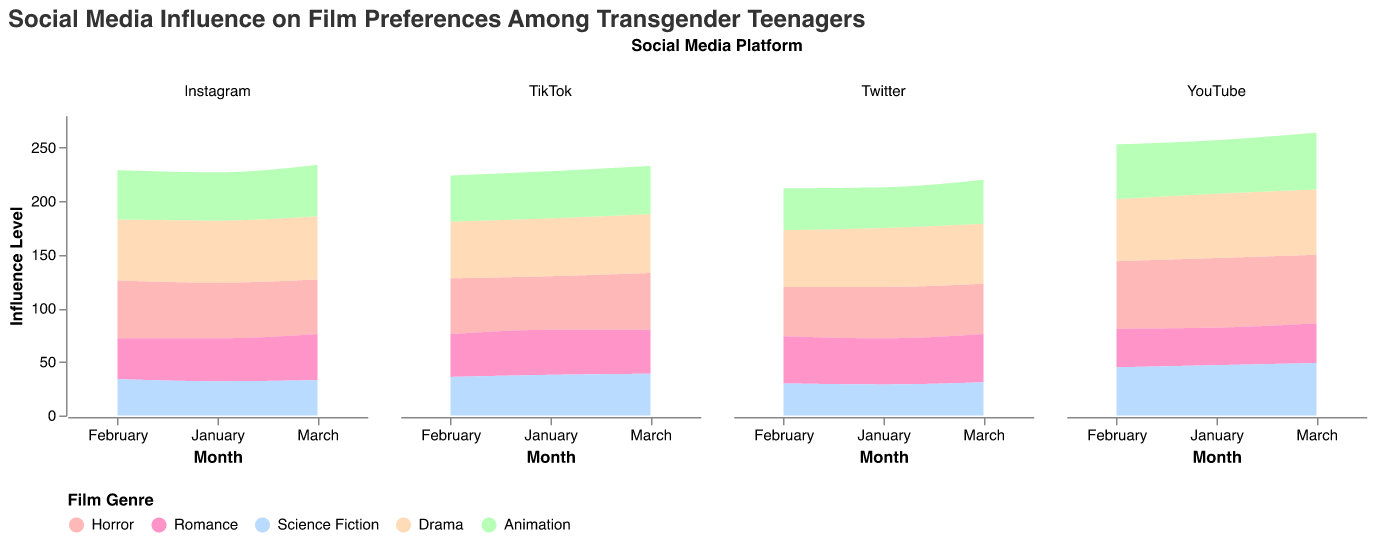What is the title of the figure? The title is displayed at the top of the chart and it briefly explains the content of the figure.
Answer: Social Media Influence on Film Preferences Among Transgender Teenagers Which month has the highest influence level for Horror films on YouTube? For YouTube, look at the area chart for the Horror genre across all months. Identify the month with the highest peak.
Answer: January What genre has the lowest influence level on Twitter in February? Refer to the Twitter subplot and look at the February data. Compare the influence levels of all genres.
Answer: Science Fiction Which platform shows the highest increase in influence level for Drama from January to March? Compare the Drama trends on each platform from January to March. The highest increase is identified by the steepest upward slope.
Answer: YouTube What is the average influence level for Romance on Instagram across the three months? Add up the Romance influence levels on Instagram for January (40), February (38), and March (43), then divide by 3.
Answer: 40.33 Between TikTok and Instagram, which platform has a higher total influence level for Science Fiction in March? Compare the sum of the influence levels for Science Fiction in March for TikTok (39) and Instagram (33).
Answer: TikTok How does the influence level for Animation on Twitter change from January to March? Examine the Animation trend on Twitter for January (38), February (39), and March (41) to identify the change.
Answer: It increases Which genre shows the most consistent influence level across all platforms and months? Consistency can be identified by looking for a genre where the influence levels have the least variation in all subplots.
Answer: Drama What is the difference in influence level for Horror on Instagram between January and February? Identify the values for Horror on Instagram in January (52) and February (54), then subtract January's value from February's.
Answer: 2 